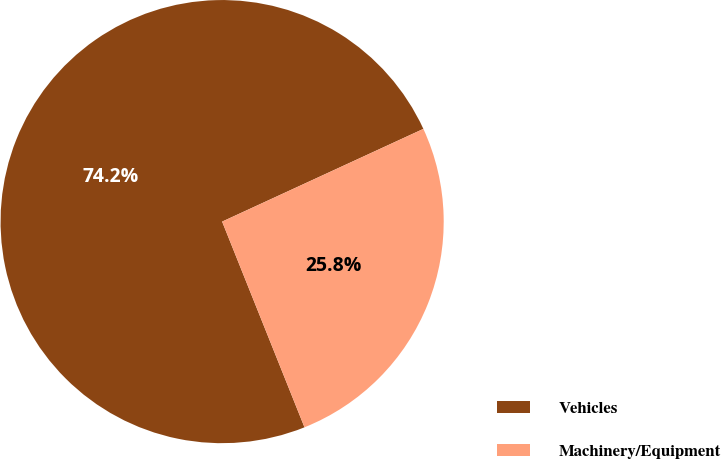Convert chart to OTSL. <chart><loc_0><loc_0><loc_500><loc_500><pie_chart><fcel>Vehicles<fcel>Machinery/Equipment<nl><fcel>74.19%<fcel>25.81%<nl></chart> 